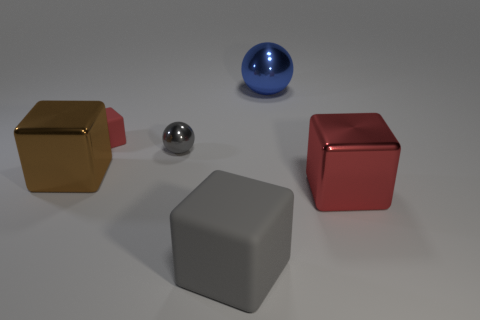Subtract all brown metal cubes. How many cubes are left? 3 Subtract all cubes. How many objects are left? 2 Add 4 big red blocks. How many objects exist? 10 Subtract 1 balls. How many balls are left? 1 Add 1 small yellow metallic things. How many small yellow metallic things exist? 1 Subtract all gray cubes. How many cubes are left? 3 Subtract 1 brown blocks. How many objects are left? 5 Subtract all brown spheres. Subtract all cyan cylinders. How many spheres are left? 2 Subtract all cyan blocks. How many blue spheres are left? 1 Subtract all red cubes. Subtract all big blue objects. How many objects are left? 3 